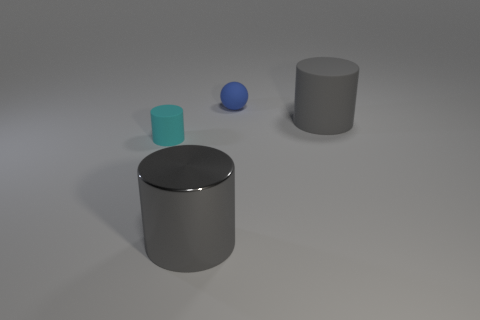What shape is the thing that is the same size as the blue sphere?
Your answer should be compact. Cylinder. Do the gray cylinder that is to the right of the blue thing and the tiny thing that is in front of the blue thing have the same material?
Give a very brief answer. Yes. Is there a big gray metal thing that is in front of the gray thing behind the tiny cyan cylinder?
Your answer should be very brief. Yes. There is another large thing that is the same material as the blue object; what is its color?
Your answer should be very brief. Gray. Is the number of gray cylinders greater than the number of large cyan shiny cylinders?
Offer a very short reply. Yes. What number of things are either cylinders in front of the big rubber object or small matte spheres?
Keep it short and to the point. 3. Are there any gray cylinders of the same size as the cyan thing?
Make the answer very short. No. Are there fewer small rubber things than metal things?
Your response must be concise. No. How many balls are tiny objects or big gray metal things?
Provide a short and direct response. 1. How many other cylinders are the same color as the shiny cylinder?
Your answer should be compact. 1. 